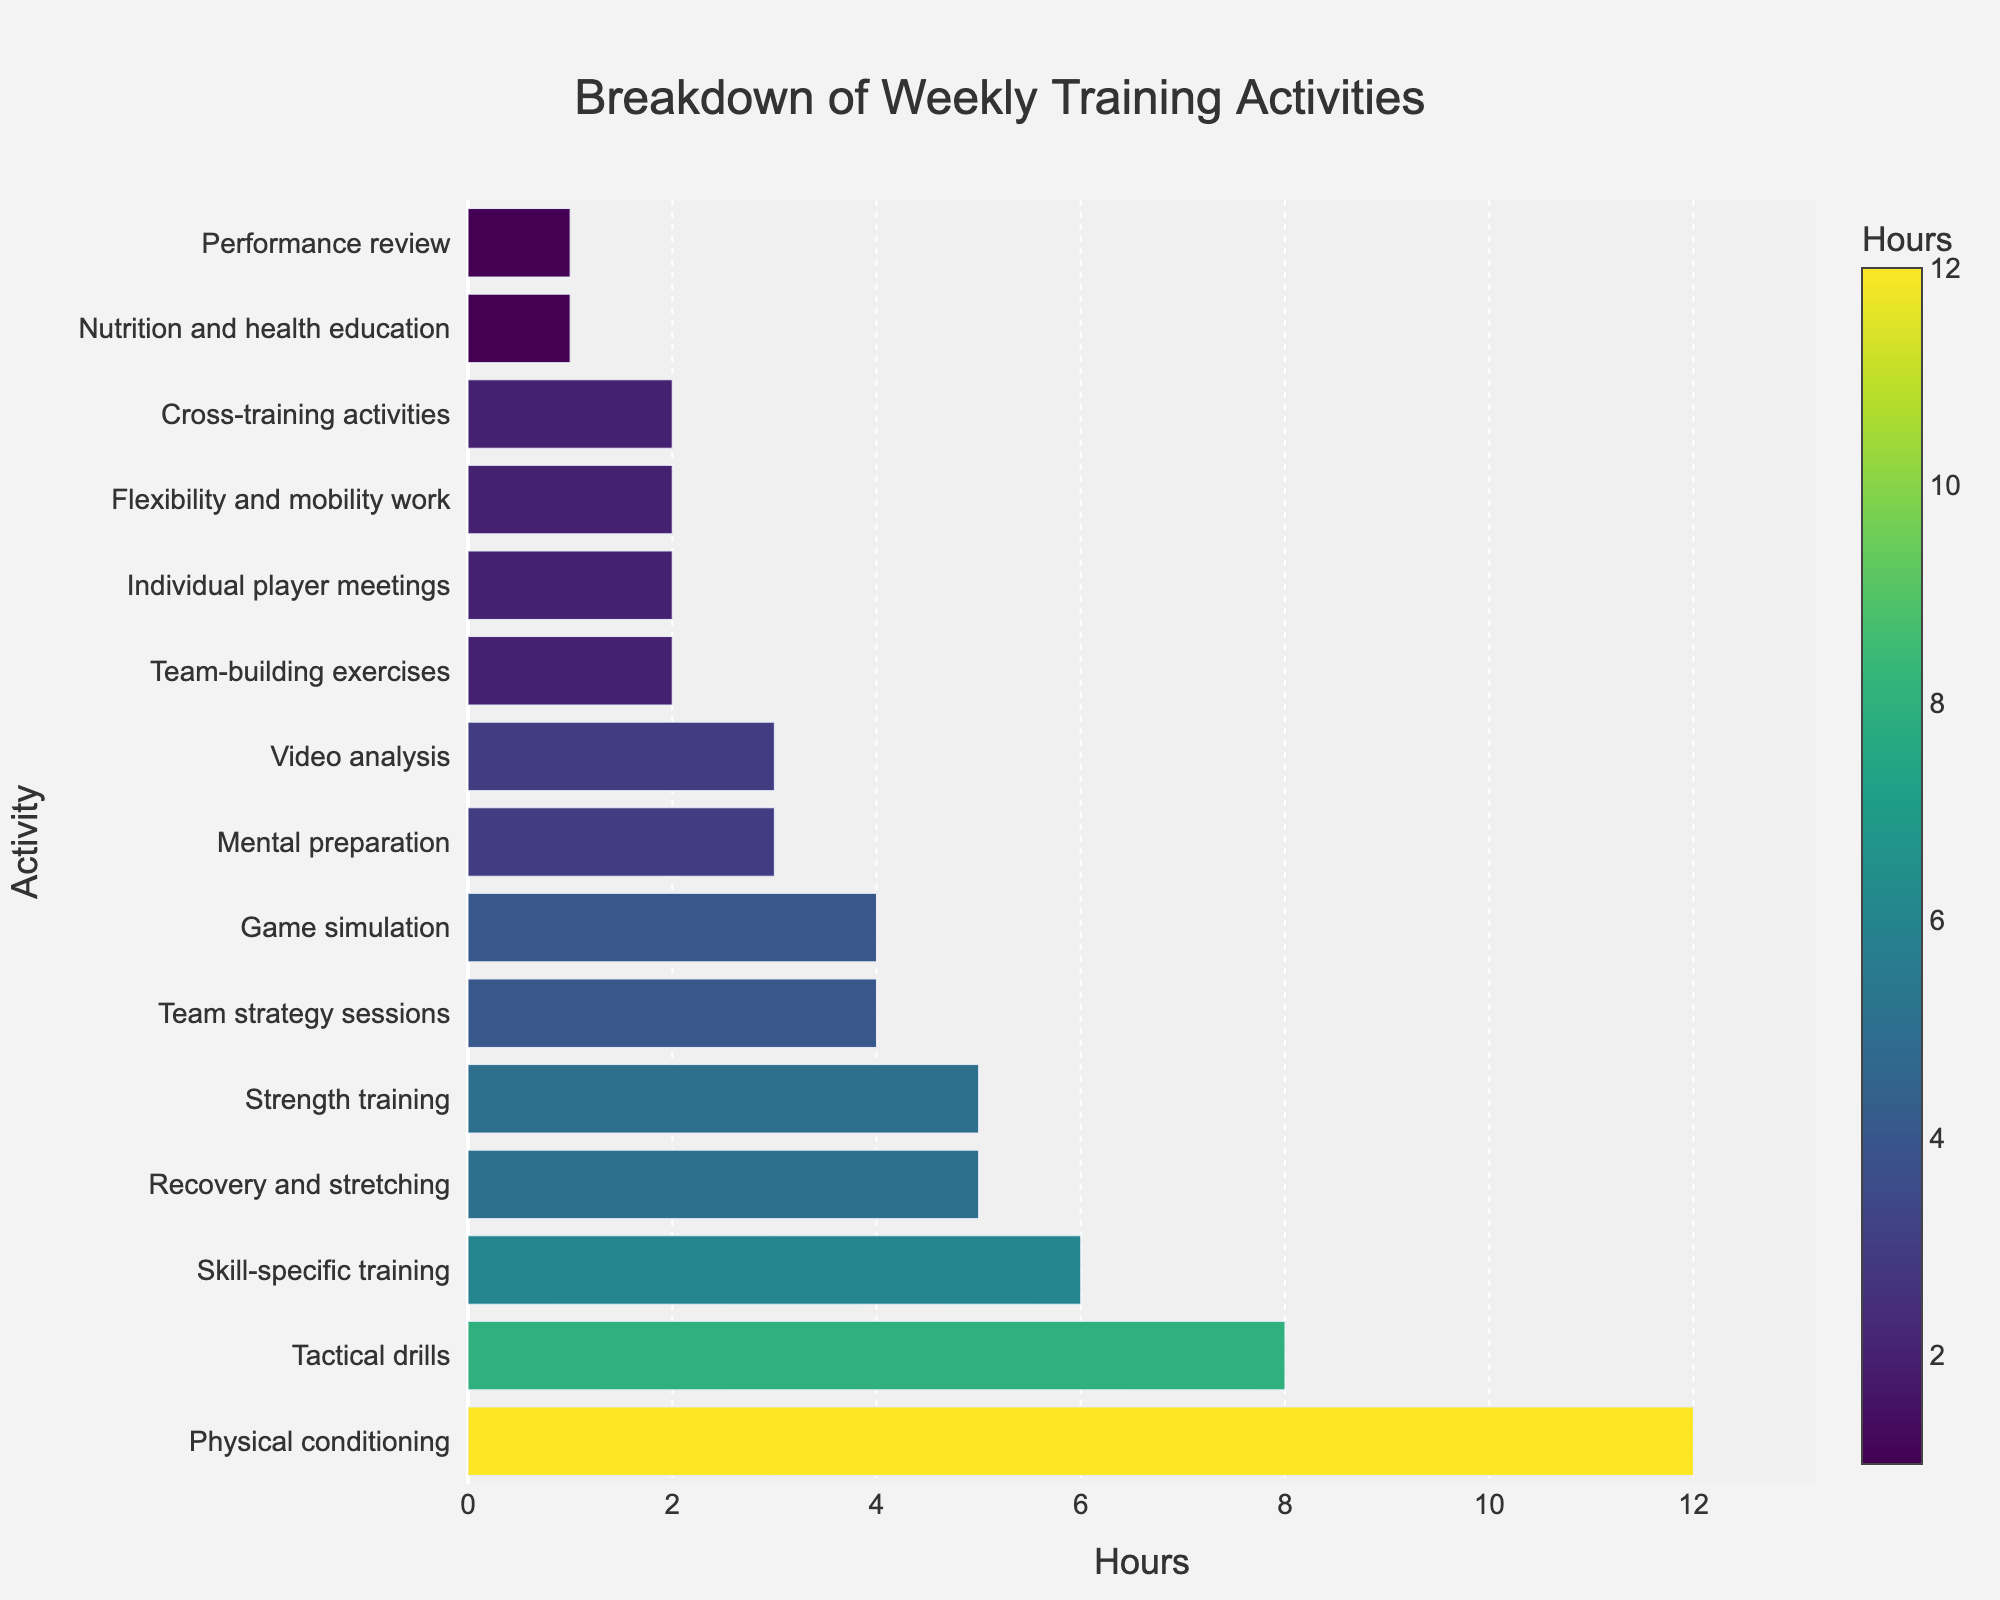Which activity takes the most hours weekly? The bar for "Physical conditioning" is the longest, indicating it takes the most hours.
Answer: Physical conditioning How many hours are spent on tactical drills compared to team strategy sessions? The bar for "Tactical drills" indicates 8 hours, and the bar for "Team strategy sessions" indicates 4 hours.
Answer: 4 hours more Which activities take the least amount of time each week? The shortest bars represent "Nutrition and health education" and "Performance review" with 1 hour each.
Answer: Nutrition and health education, Performance review How many total hours are spent on both physical conditioning and mental preparation? Add the hours for "Physical conditioning" (12) and "Mental preparation" (3).
Answer: 15 hours What is the combined time spent on skill-specific training and strength training? The hours for "Skill-specific training" is 6, and for "Strength training" is 5. Their sum is 11 hours.
Answer: 11 hours Compare the time spent on skill-specific training and game simulation. Which takes more time and by how much? The bar for "Skill-specific training" (6 hours) is longer than "Game simulation" (4 hours), so skill-specific training takes 2 more hours.
Answer: Skill-specific training, 2 hours What's the average number of hours spent on the activities which last 5 hours each? "Strength training" and "Recovery and stretching" both last 5 hours, so (5 + 5) / 2 = 5.
Answer: 5 hours What's the difference in hours between the activities with the longest and shortest durations? The longest duration is "Physical conditioning" at 12 hours and the shortest are "Nutrition and health education" and "Performance review" at 1 hour. The difference is 12 - 1 = 11 hours.
Answer: 11 hours What is the total time spent on recovery, stretching, and flexibility and mobility work? Add the hours for "Recovery and stretching" (5) and "Flexibility and mobility work" (2).
Answer: 7 hours Compare the time spent on team-related activities (team strategy sessions and team-building exercises) to individual-focused activities (individual player meetings). Which group has more hours and by how many? Add hours for team-related (4 + 2 = 6) and individual-focused (2). Team-related activities have more hours (6 - 2 = 4).
Answer: Team-related, 4 hours 